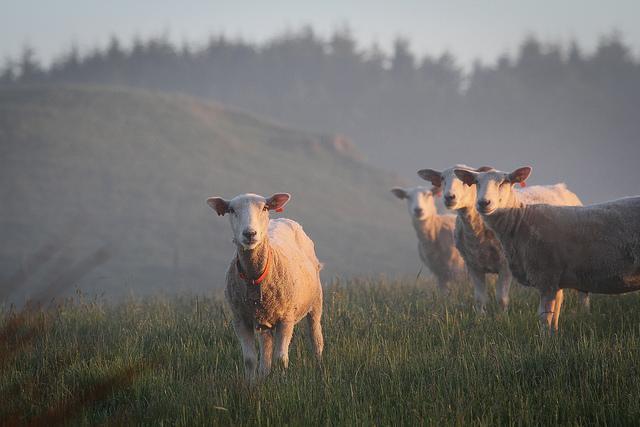How many animals are in the picture?
Give a very brief answer. 4. How many horns are on the animals?
Give a very brief answer. 0. How many sheep are in the picture?
Give a very brief answer. 4. 